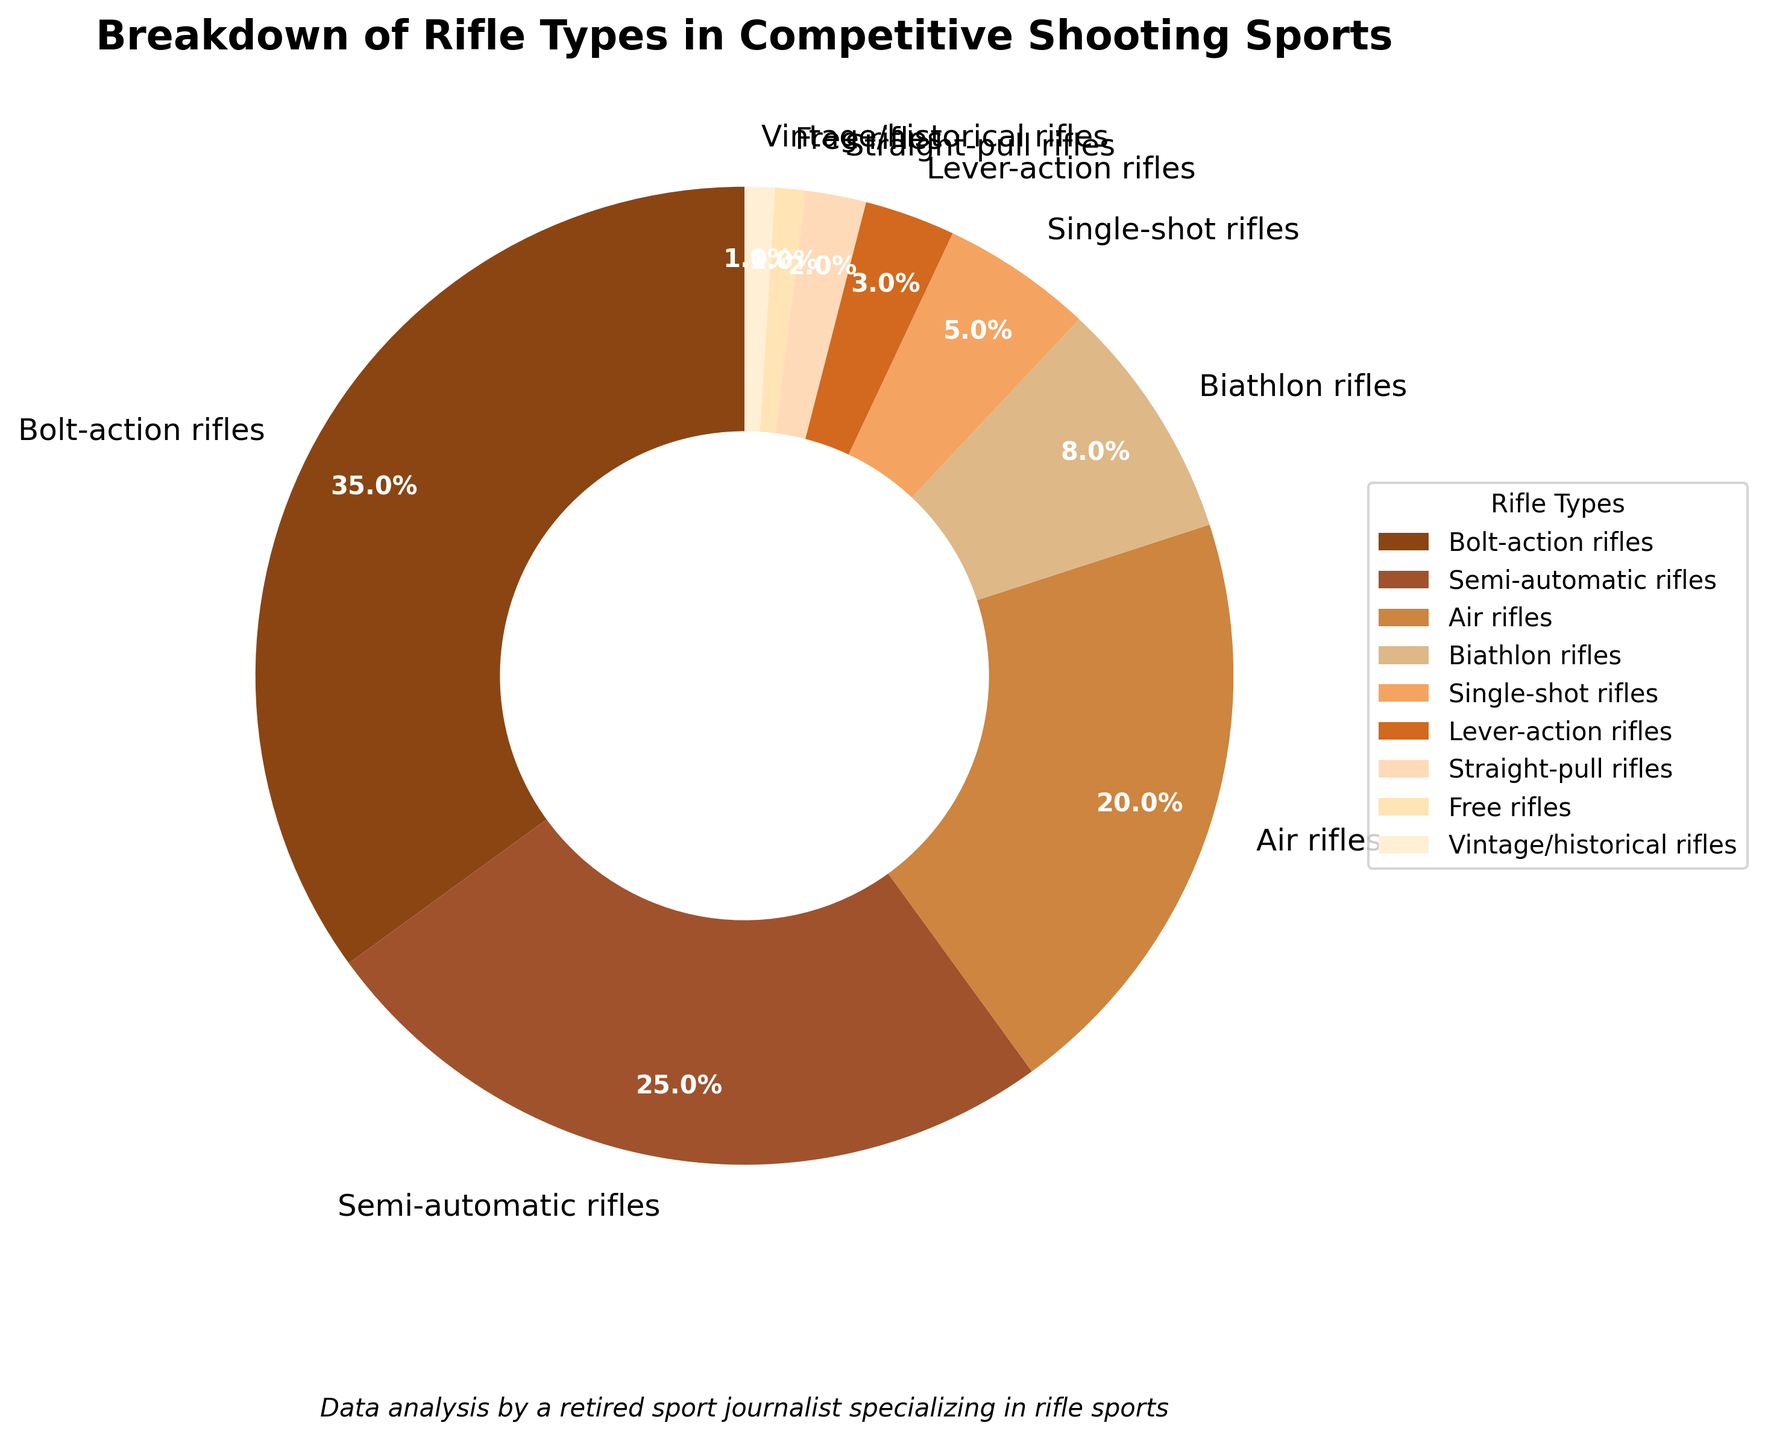Which rifle type has the highest percentage usage in competitive shooting sports? The pie chart shows that Bolt-action rifles have the highest percentage usage.
Answer: Bolt-action rifles Which three rifle types together make up more than 50% of the total usage? Adding the percentages of Bolt-action rifles (35%), Semi-automatic rifles (25%), and Air rifles (20%), we get 35 + 25 + 20 = 80%, which is more than 50%.
Answer: Bolt-action rifles, Semi-automatic rifles, Air rifles How much more popular are Bolt-action rifles compared to Lever-action rifles? The percentage for Bolt-action rifles is 35%, and for Lever-action rifles, it is 3%. The difference is 35 - 3 = 32%.
Answer: 32% What is the combined percentage of Biathlon rifles and Single-shot rifles? The percentage for Biathlon rifles is 8%, and for Single-shot rifles, it is 5%. Adding them together, we get 8 + 5 = 13%.
Answer: 13% Which rifle type is used more, Air rifles or Biathlon rifles? By how much? Air rifles have a percentage of 20%, while Biathlon rifles have a percentage of 8%. The difference is 20 - 8 = 12%.
Answer: Air rifles, by 12% What percentage of the total is made up by the least popular rifle types (categories under 5%)? The least popular rifle types are Single-shot (5%), Lever-action (3%), Straight-pull (2%), Free rifles (1%), and Vintage/historical rifles (1%). Adding them, we get 5 + 3 + 2 + 1 + 1 = 12%.
Answer: 12% Which category represents the smallest segment? The pie chart shows that Free rifles and Vintage/historical rifles each have the smallest segment at 1%.
Answer: Free rifles, Vintage/historical rifles Are there more or fewer than 10% of Lever-action and Free rifles combined? Lever-action rifles have 3% and Free rifles have 1%. Adding them together, we get 3 + 1 = 4%, which is less than 10%.
Answer: Fewer, 4% 